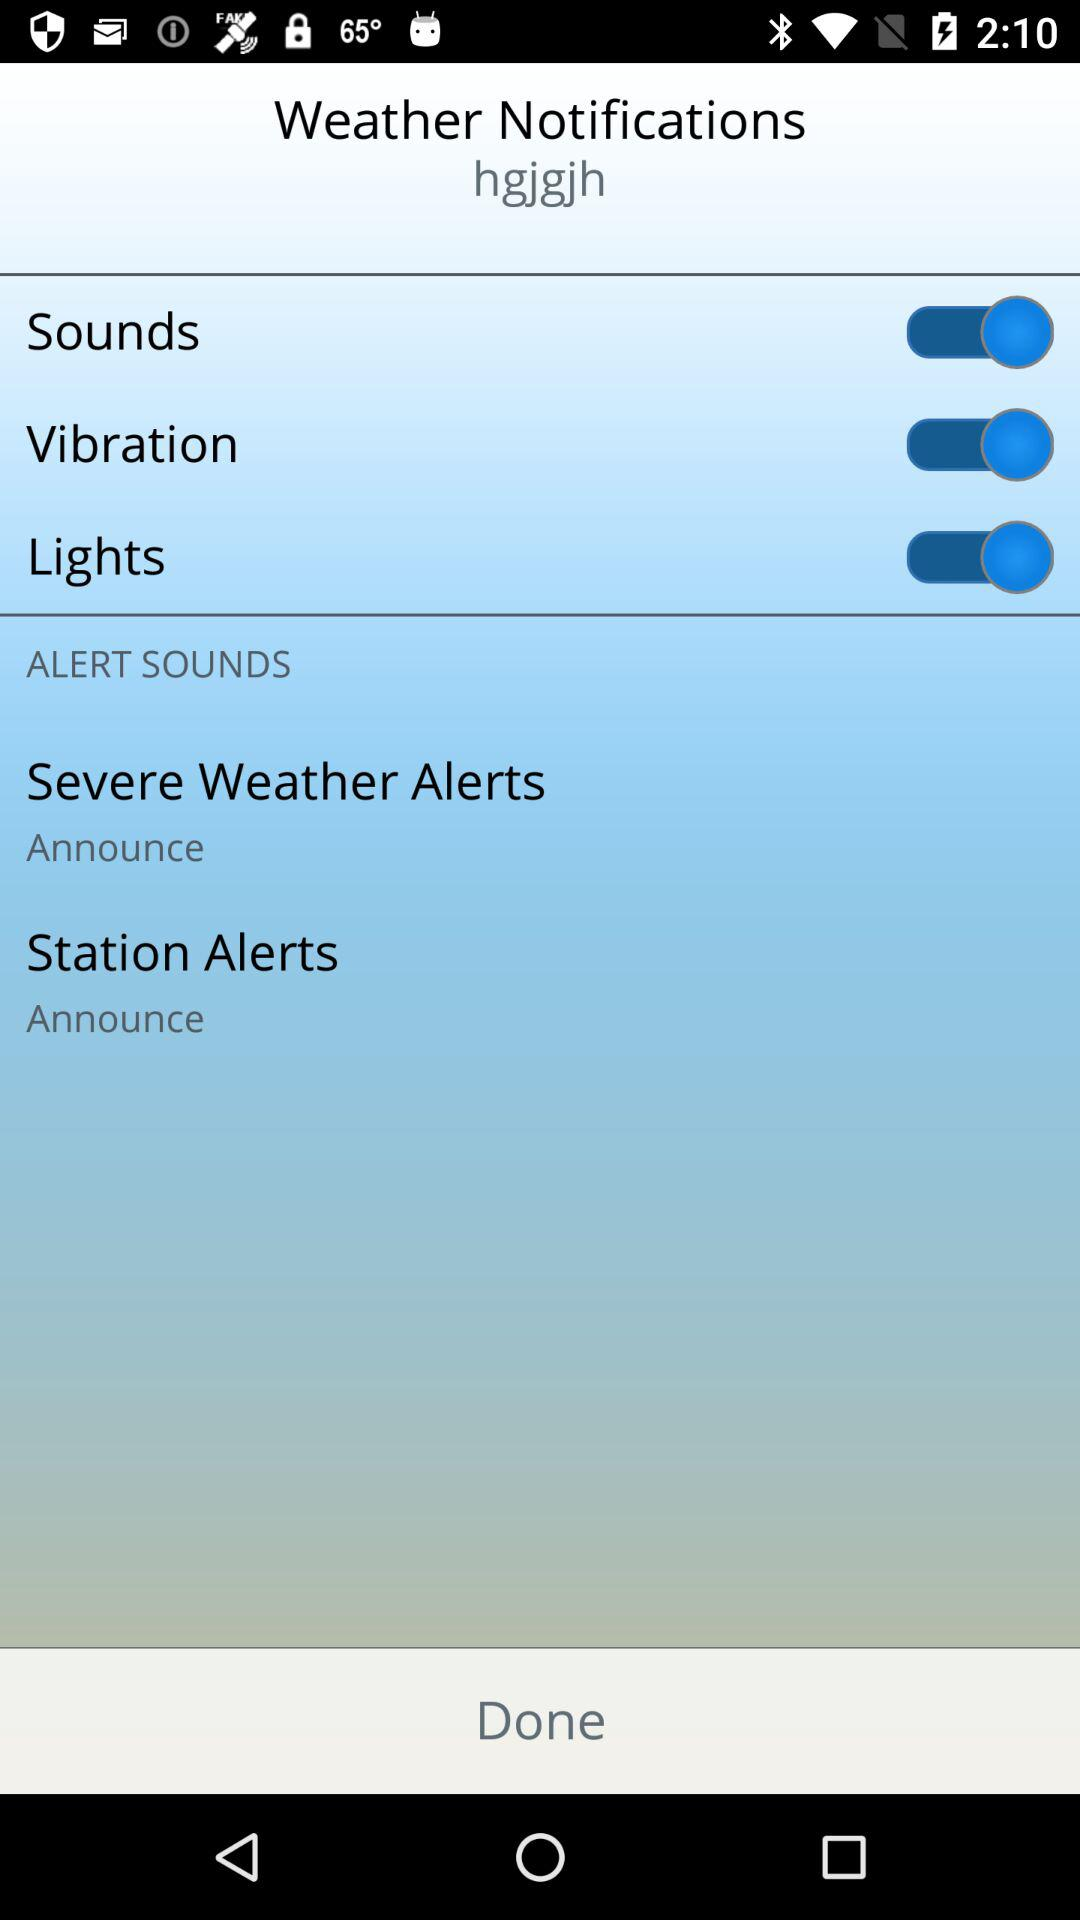How many alert sounds can I choose from?
Answer the question using a single word or phrase. 2 